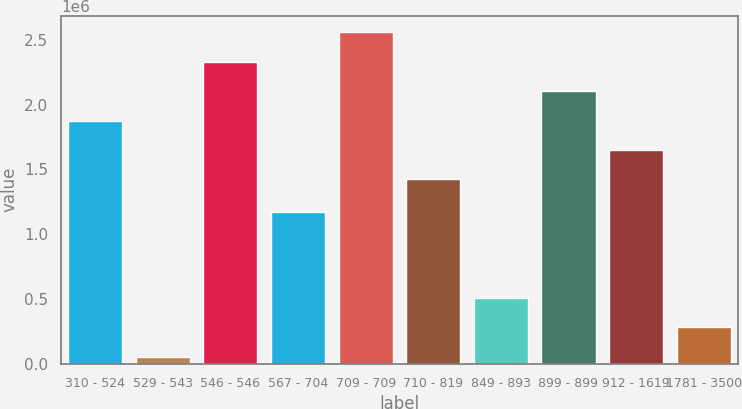Convert chart. <chart><loc_0><loc_0><loc_500><loc_500><bar_chart><fcel>310 - 524<fcel>529 - 543<fcel>546 - 546<fcel>567 - 704<fcel>709 - 709<fcel>710 - 819<fcel>849 - 893<fcel>899 - 899<fcel>912 - 1619<fcel>1781 - 3500<nl><fcel>1.87826e+06<fcel>53000<fcel>2.3322e+06<fcel>1.17154e+06<fcel>2.55917e+06<fcel>1.42432e+06<fcel>506940<fcel>2.10523e+06<fcel>1.65129e+06<fcel>279970<nl></chart> 